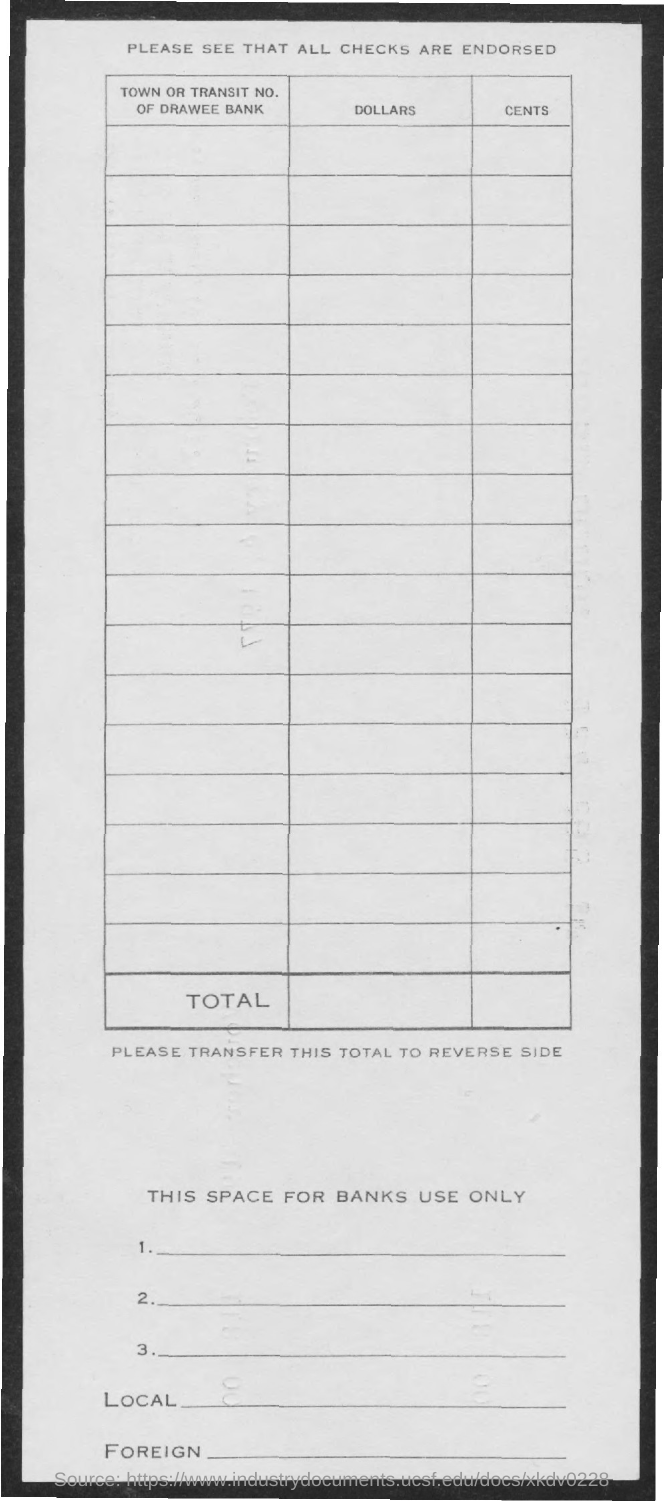What is the first title in the document?
Keep it short and to the point. Please see that all checks are endorsed. What is the title of the first column of the table?
Provide a short and direct response. Town or transit no. of drawee bank. What is the title of the second column of the table?
Ensure brevity in your answer.  Dollars. What is the title of the third column of the table?
Ensure brevity in your answer.  Cents. 